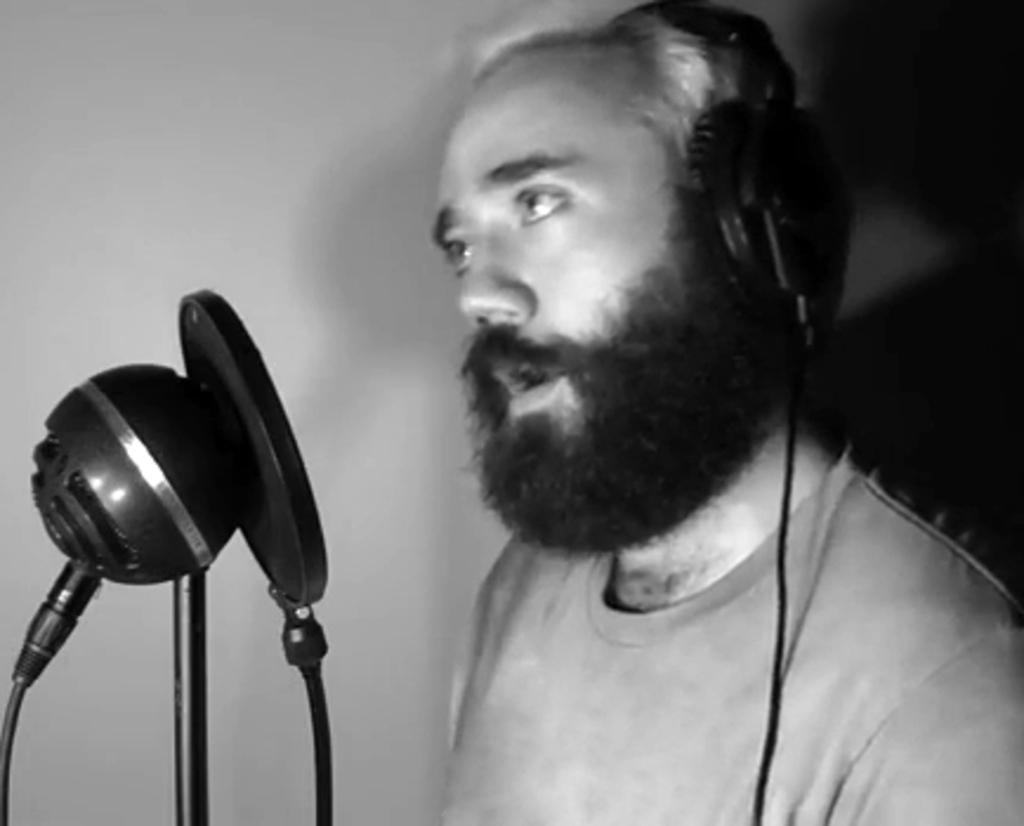What is the man in the image doing? The man is standing and singing in the image. What object is present on the left side of the image? There is a microphone on the left side of the image. What can be seen in the background of the image? There is a wall in the background of the image. What type of deer can be seen in the image? There are no deer present in the image. How does the man's mind influence the sound of his singing in the image? The image does not provide information about the man's mind or how it might influence his singing. 